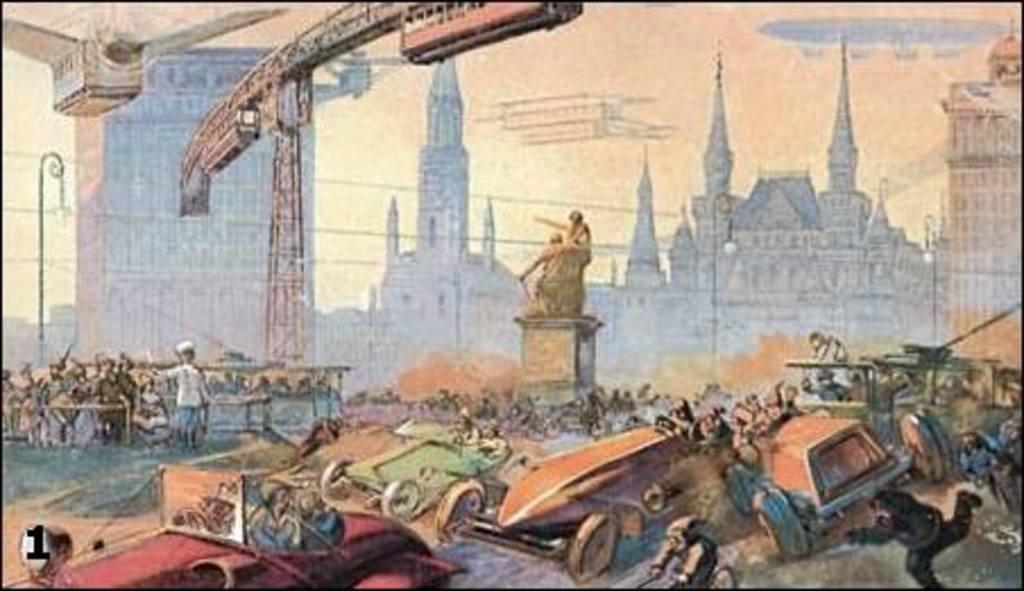What type of objects are depicted in the painted image? The painted image contains buildings, scepters, persons, and vehicles. Can you describe the subjects in the painted image? The painted image contains persons, who are likely interacting with the buildings, scepters, and vehicles. What is the overall theme or setting of the painted image? Based on the presence of buildings, scepters, persons, and vehicles, the painted image may depict a scene from a city or urban environment. Is there a mountain visible in the painted image? No, there is no mountain present in the painted image. Can you describe the kick performed by one of the persons in the painted image? There is no kick performed by any person in the painted image, as the provided facts do not mention any such action. 